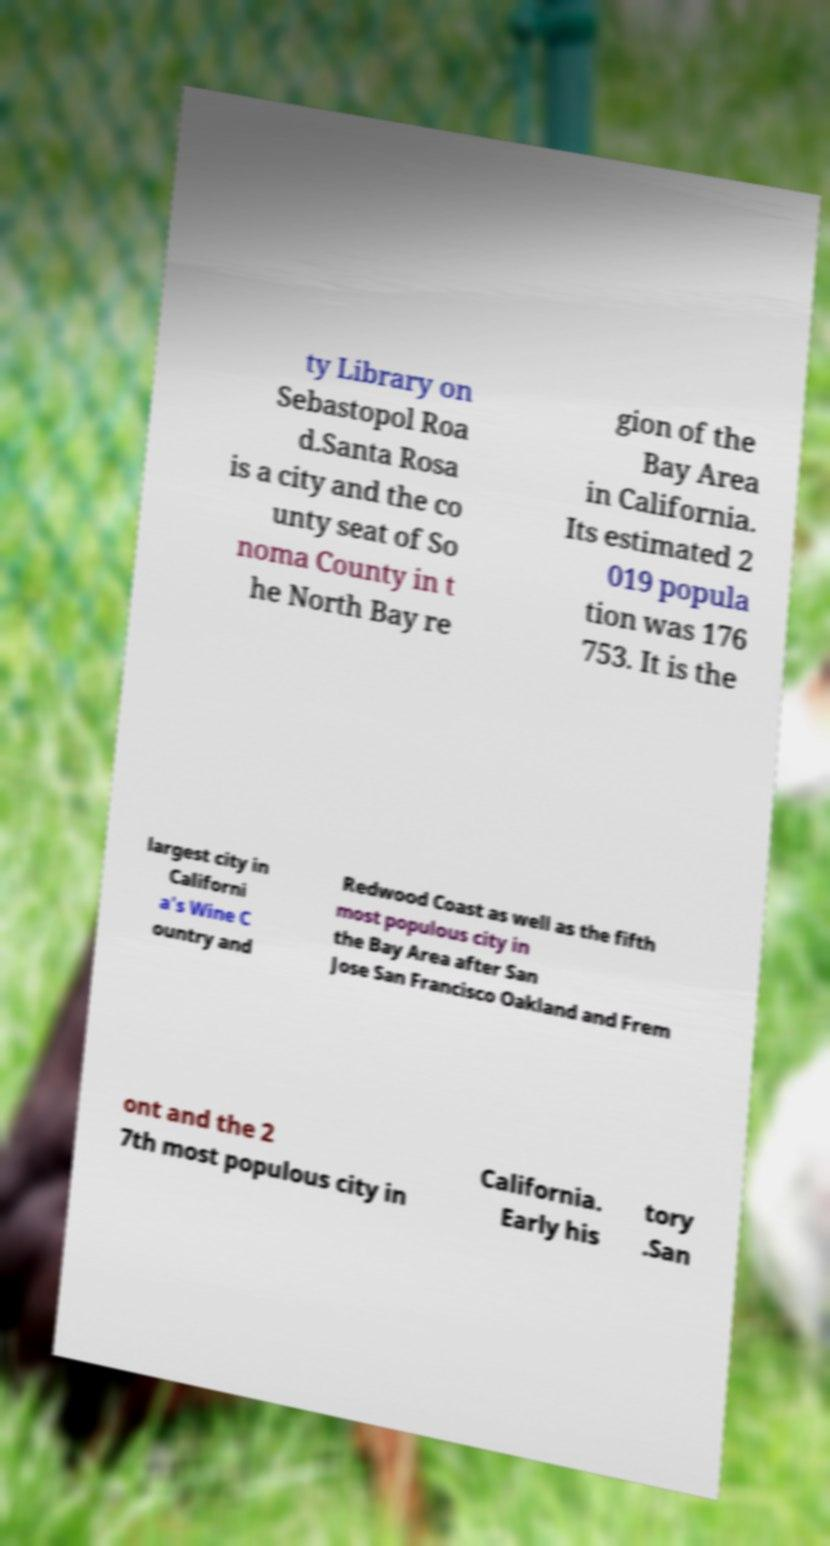Can you read and provide the text displayed in the image?This photo seems to have some interesting text. Can you extract and type it out for me? ty Library on Sebastopol Roa d.Santa Rosa is a city and the co unty seat of So noma County in t he North Bay re gion of the Bay Area in California. Its estimated 2 019 popula tion was 176 753. It is the largest city in Californi a's Wine C ountry and Redwood Coast as well as the fifth most populous city in the Bay Area after San Jose San Francisco Oakland and Frem ont and the 2 7th most populous city in California. Early his tory .San 